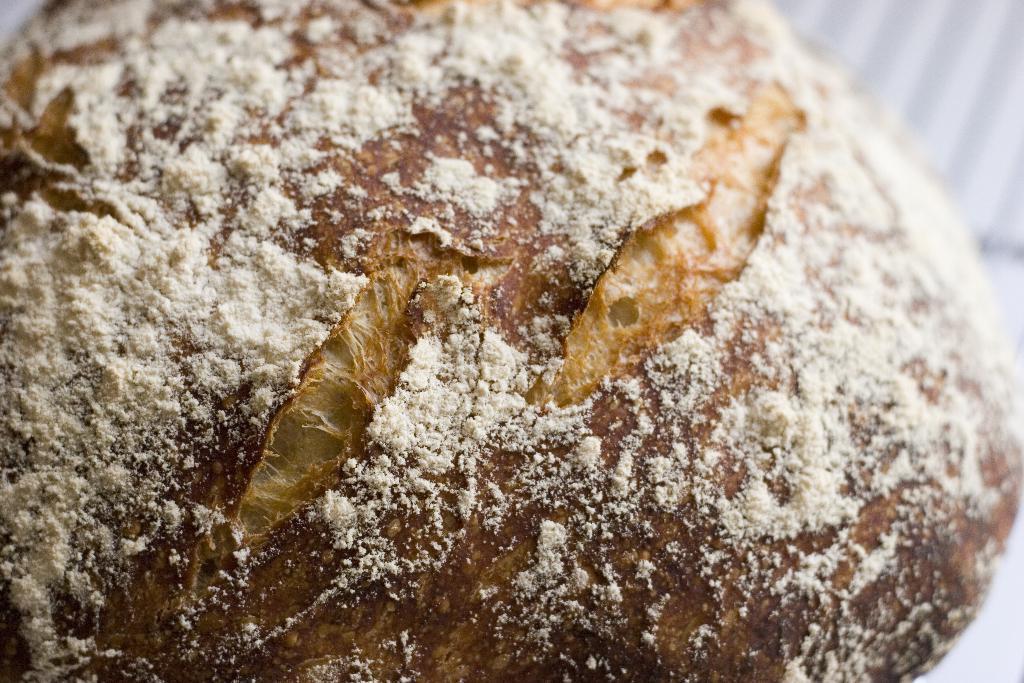Could you give a brief overview of what you see in this image? In this picture we can see food. 